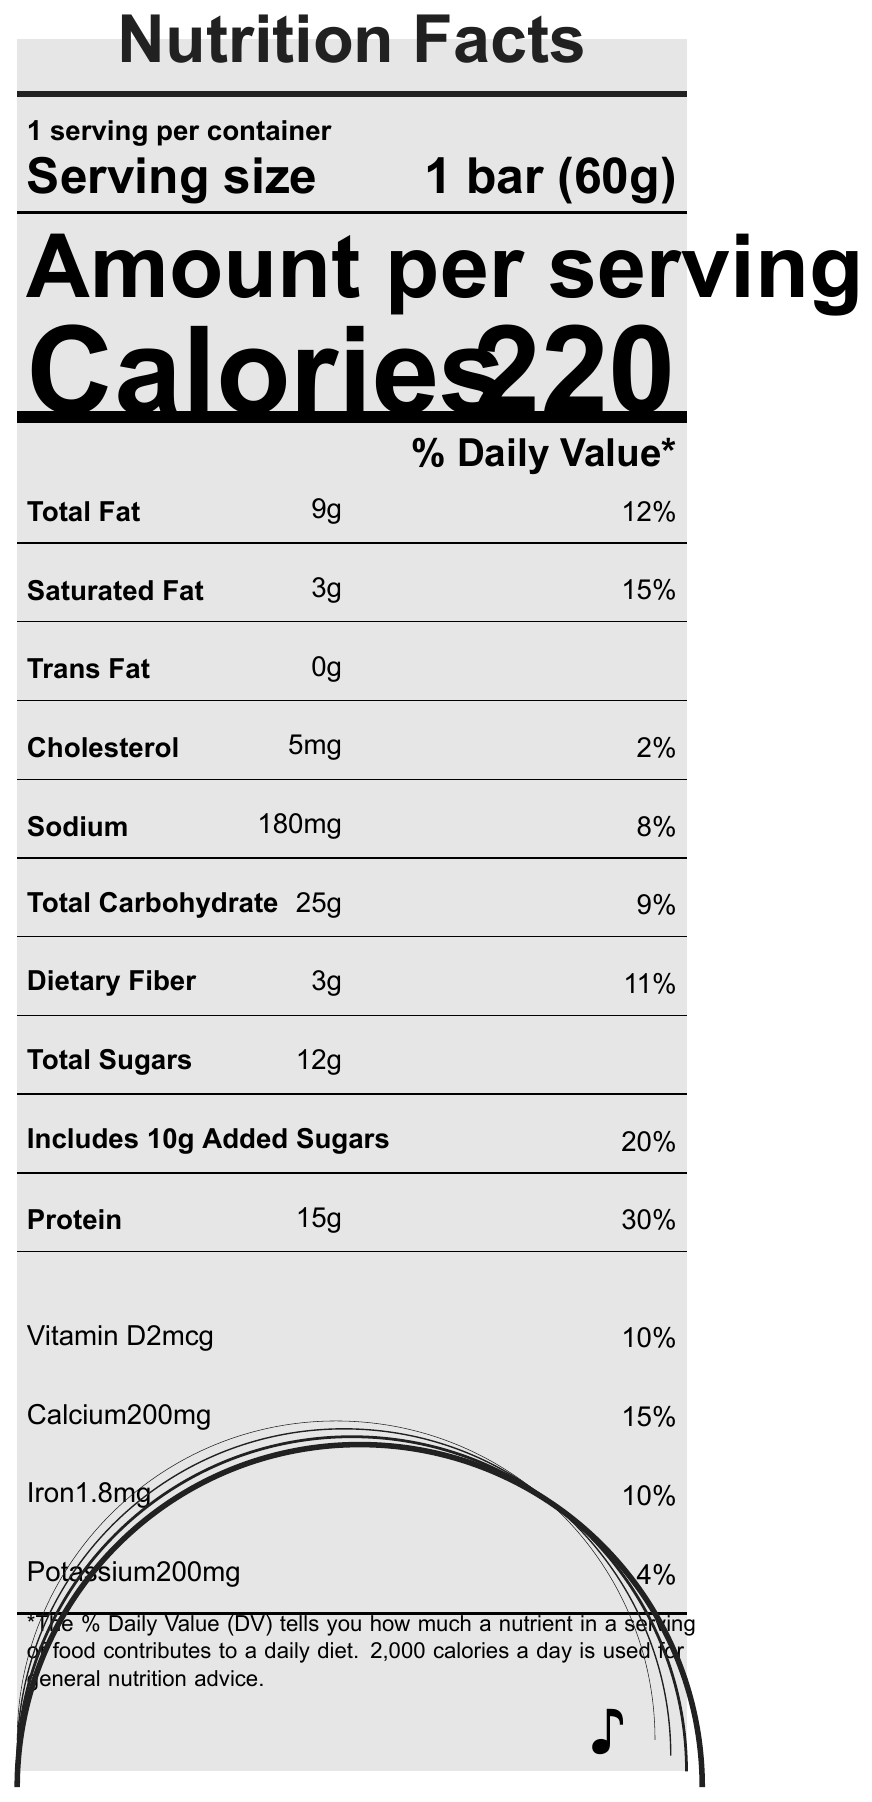what is the serving size of the Vinyl Groove Protein Bar? The serving size is mentioned right under "Serving size" and is given as 1 bar (60g).
Answer: 1 bar (60g) how many calories does one serving of the Vinyl Groove Protein Bar contain? The number of calories per serving is displayed prominently under "Calories" as 220.
Answer: 220 what percentage of the daily value for protein does one serving provide? This information is found under the "Protein" section, where it states the amount as "15g" and the daily value percentage as "30%".
Answer: 30% what is the amount of total fat in one serving? The total fat content is listed under "Total Fat" as 9g with a daily value percentage of 12%.
Answer: 9g what special features does the Vinyl Groove Protein Bar have? These special features are listed under the "specialFeatures" section.
Answer: Non-GMO, Gluten-free, No artificial preservatives does the Vinyl Groove Protein Bar contain any trans fats? Under "Trans Fat," the amount is listed as 0g, indicating there are no trans fats.
Answer: No which ingredient is listed first in the ingredients list? A. Brown rice syrup B. Whey protein isolate C. Almonds D. Cocoa powder The first ingredient listed under "ingredients" is Whey protein isolate.
Answer: B. Whey protein isolate how much sodium is in one serving? A. 120mg B. 180mg C. 220mg D. 150mg The sodium content in one serving is 180mg, which is listed with a daily value percentage of 8%.
Answer: B. 180mg does the Vinyl Groove Protein Bar contain any milk or tree nuts? Under "allergens," it states that the bar contains milk and tree nuts (almonds).
Answer: Yes is the Vinyl Groove Protein Bar gluten-free? The "specialFeatures" section lists it as gluten-free.
Answer: Yes what percent daily value of dietary fiber does one serving provide? The dietary fiber content is listed as 3g with an 11% daily value.
Answer: 11% how much added sugars does one serving contain? The total sugars and the specific amount of added sugars are listed under "Total Sugars" and "Includes 10g Added Sugars."
Answer: 10g what is the address of the manufacturer? The manufacturer's address is listed under "manufacturerInfo" as 1234 Turntable Avenue, Groovytown, CA 90210.
Answer: 1234 Turntable Avenue, Groovytown, CA 90210 what is the percentage of daily iron value provided by one bar? A. 4% B. 10% C. 8% D. 6% The percentage daily value for iron is listed as 10%.
Answer: B. 10% how many grams of saturated fat are in one serving? The saturated fat content is listed under "Saturated Fat" as 3g with a daily value percentage of 15%.
Answer: 3g what percent daily value of calcium does one serving provide? The calcium content is listed as 200mg with a 15% daily value.
Answer: 15% what is the total carbohydrate content per serving? The total carbohydrate content is listed under "Total Carbohydrate" as 25g with a daily value percentage of 9%.
Answer: 25g does the Vinyl Groove Protein Bar contain any preservatives? The "specialFeatures" section explicitly mentions that there are no artificial preservatives.
Answer: No what is unique about the shape and packaging of the Vinyl Groove Protein Bar? The "musicalNotes" section explains that the bar is shaped like a miniature vinyl record, complete with grooves, and the packaging includes a QR code linking to a curated playlist.
Answer: Shaped like a miniature vinyl record, includes a QR code linking to a curated playlist summarize the main features of the Vinyl Groove Protein Bar. The document provides detailed nutritional information, highlighting its caloric content, macronutrient breakdown, special dietary features, and unique branding elements that play on musical themes.
Answer: The Vinyl Groove Protein Bar is a 60g, 220-calorie snack with 9g of total fat, 15g of protein, and 25g of carbohydrates. It contains important nutrients such as calcium, iron, and vitamin D, and has special features like being non-GMO, gluten-free, and having no artificial preservatives. The bar is shaped like a vinyl record, reflecting its musical theme. what is the price of the Vinyl Groove Protein Bar? The document does not provide any information regarding the price of the Vinyl Groove Protein Bar.
Answer: Not enough information 